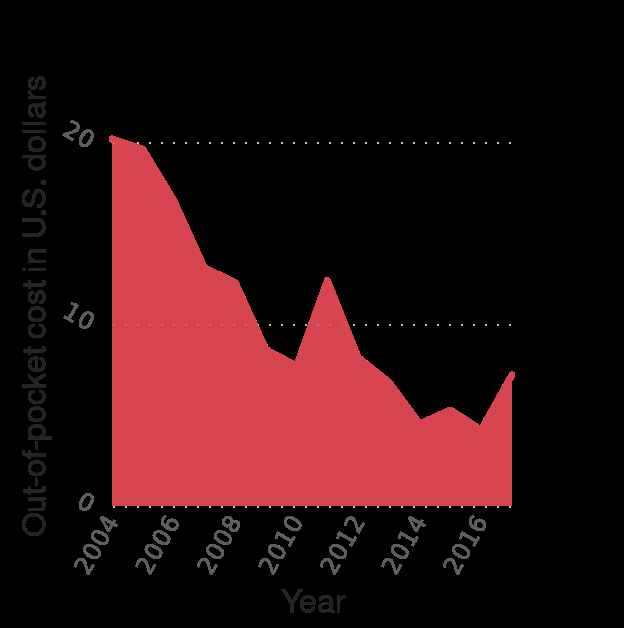<image>
What was the lowest out-of-pocket cost mentioned in the figure?  The lowest out-of-pocket cost mentioned was 4 dollars in 2014. please enumerates aspects of the construction of the chart Alprazolam out-of-pocket cost in the U.S. from 2004 to 2017 (in U.S. dollars) is a area graph. The x-axis plots Year as linear scale with a minimum of 2004 and a maximum of 2016 while the y-axis shows Out-of-pocket cost in U.S. dollars using linear scale with a minimum of 0 and a maximum of 20. What type of graph is used to represent the Alprazolam out-of-pocket cost in the U.S. from 2004 to 2017?  An area graph is used to represent the Alprazolam out-of-pocket cost in the U.S. from 2004 to 2017. What information does the y-axis of the graph convey? The y-axis of the graph shows the out-of-pocket cost in U.S. dollars. Was the highest out-of-pocket cost mentioned 4 dollars in 2014? No. The lowest out-of-pocket cost mentioned was 4 dollars in 2014. 